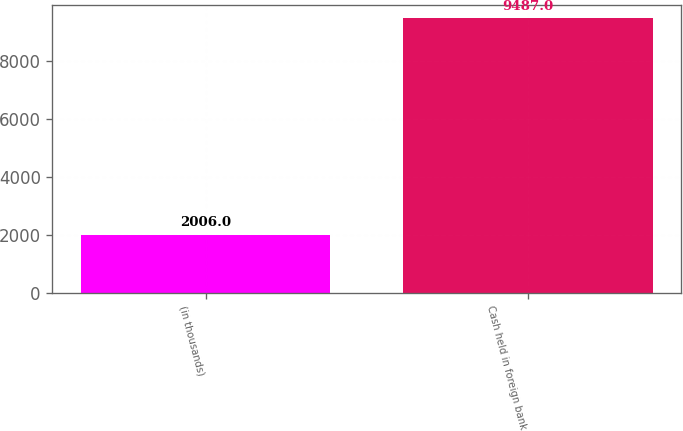Convert chart. <chart><loc_0><loc_0><loc_500><loc_500><bar_chart><fcel>(in thousands)<fcel>Cash held in foreign bank<nl><fcel>2006<fcel>9487<nl></chart> 